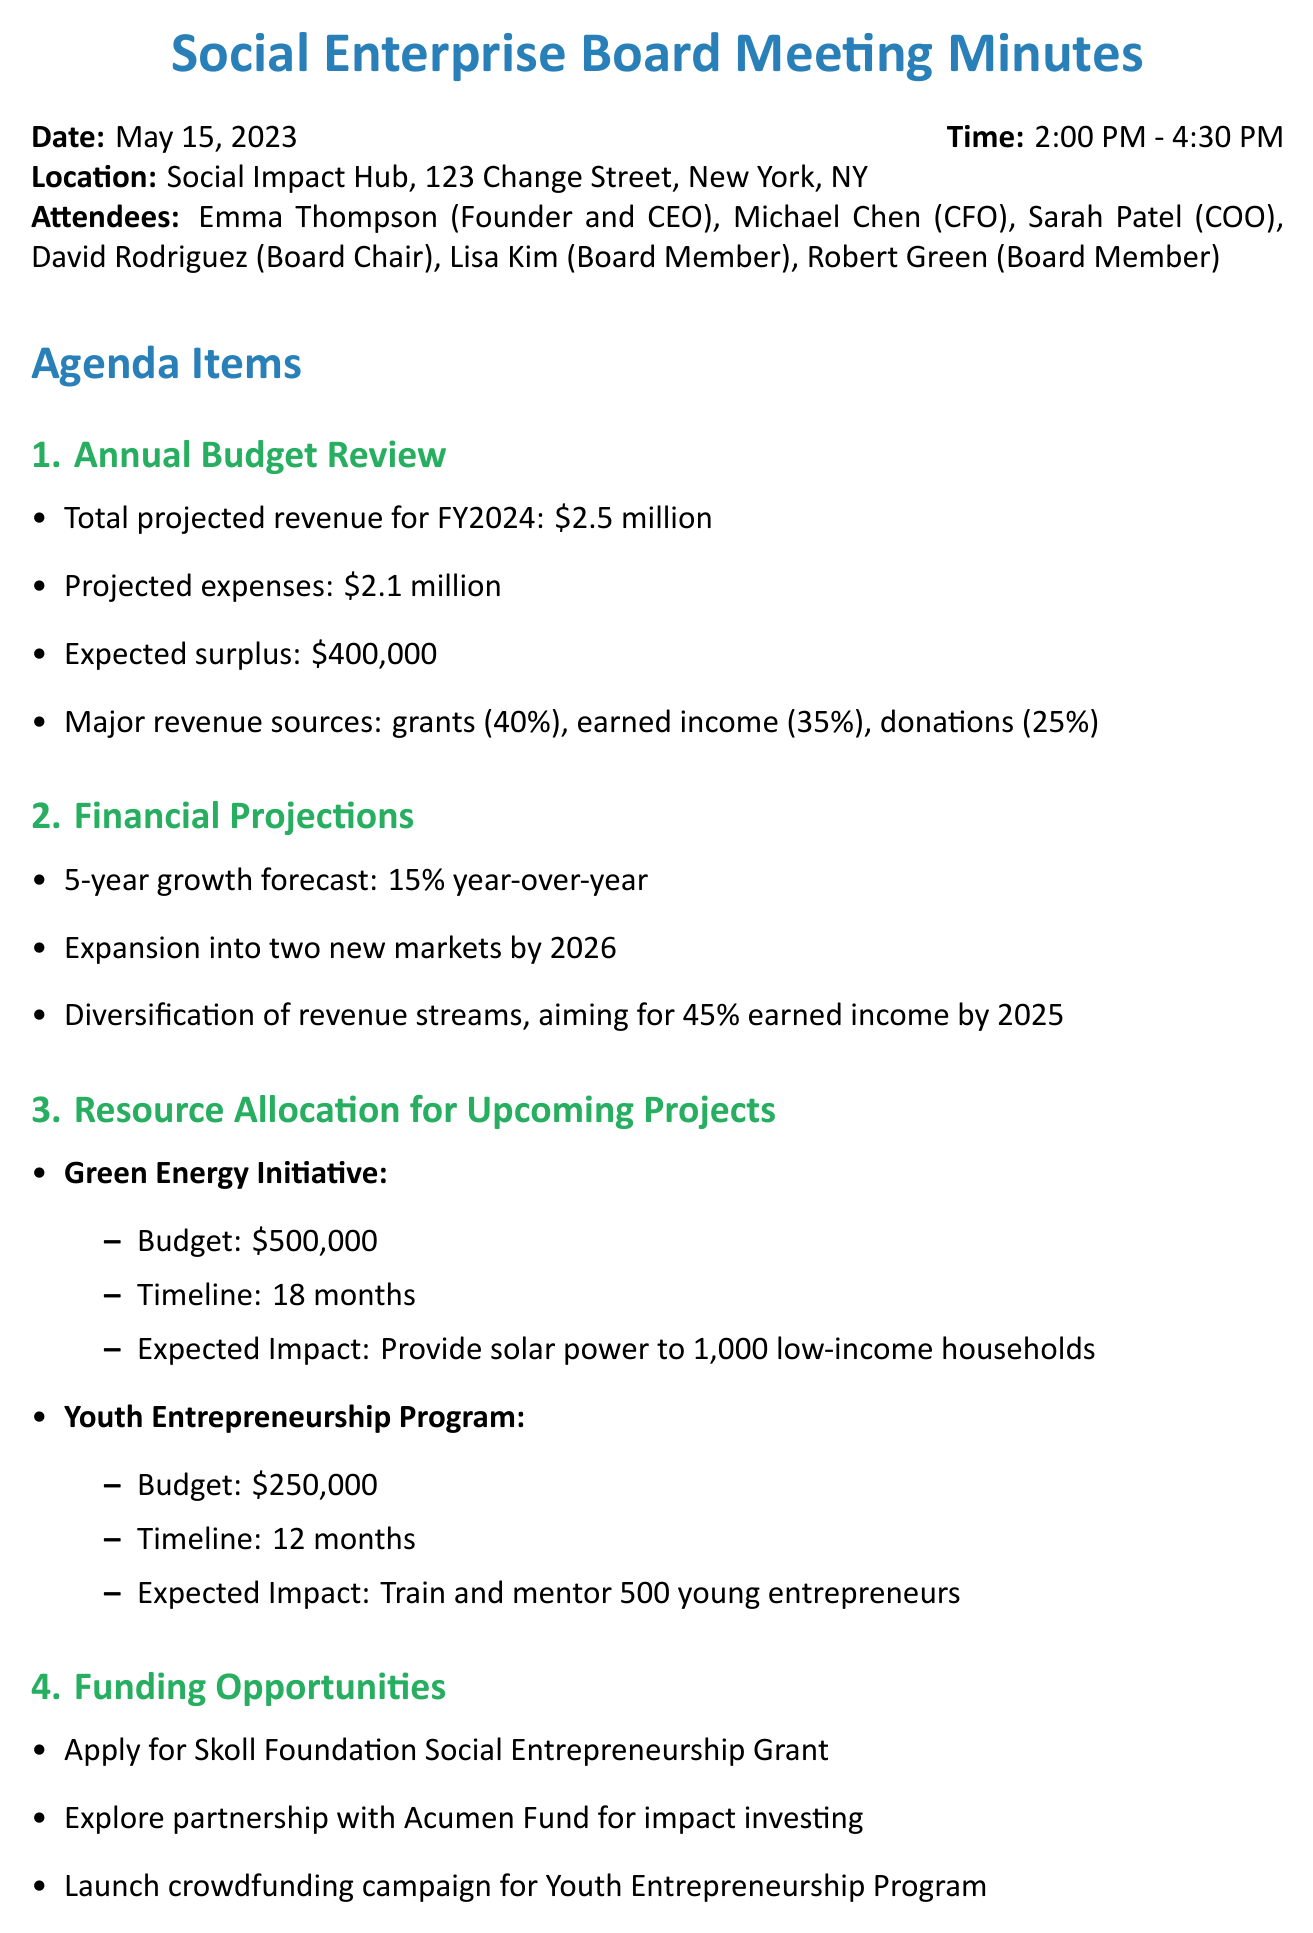What is the total projected revenue for FY2024? The total projected revenue for FY2024 is explicitly stated in the document.
Answer: $2.5 million What is the budget for the Green Energy Initiative? The budget for the Green Energy Initiative is detailed in the resource allocation section.
Answer: $500,000 Who is the Board Chair? The document lists the attendees, including the Board Chair.
Answer: David Rodriguez When is the next meeting scheduled? The next meeting's date is mentioned at the end of the document.
Answer: August 15, 2023 What percentage of revenue is expected from grants? The major revenue sources include specific percentages, which are outlined in the annual budget review.
Answer: 40% Which project has a budget of $250,000? The document specifies the budgets for each upcoming project, allowing identification.
Answer: Youth Entrepreneurship Program What is the expected impact of the Green Energy Initiative? The expected impact is outlined in the resource allocation section of the document.
Answer: Provide solar power to 1,000 low-income households What action is Emma responsible for before June 1st? The action items section lists specific tasks assigned to different attendees.
Answer: Finalize grant application for Skoll Foundation 